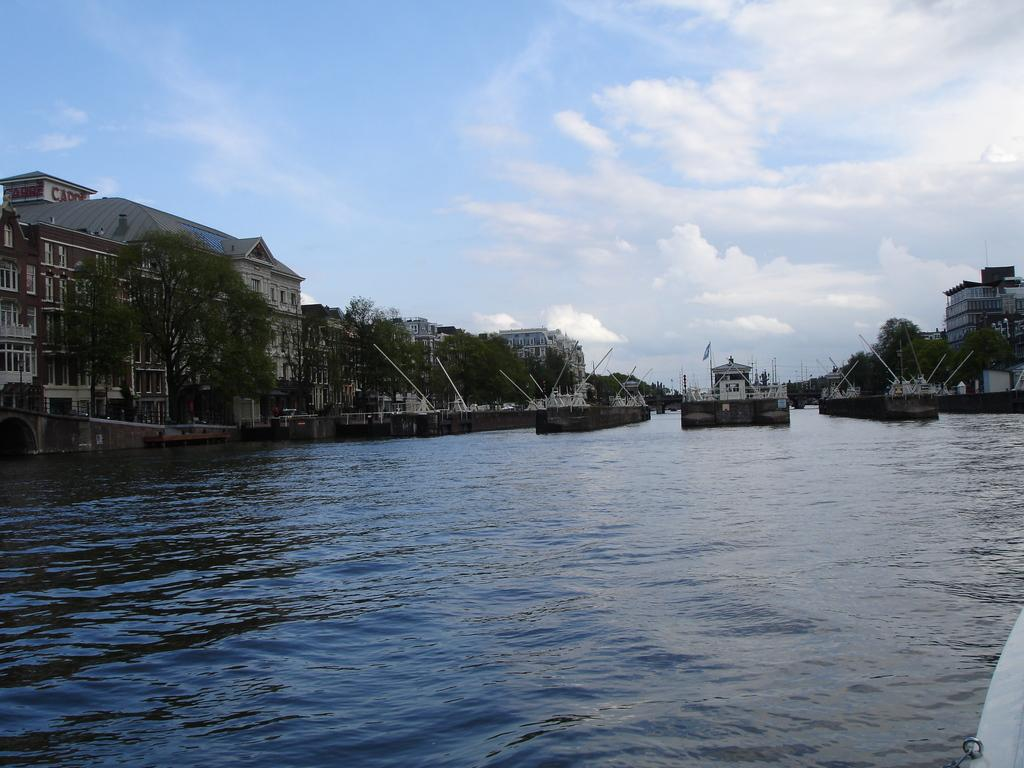What is present at the bottom of the image? There is water at the bottom of the image. What can be seen in the middle of the image? There are trees and buildings in the middle of the image. What is visible at the top of the image? The sky is visible at the top of the image. What is the condition of the sky in the image? The sky is cloudy in the image. How many legs can be seen on the volcano in the image? There is no volcano present in the image. What type of umbrella is being used by the trees in the image? There are no umbrellas present in the image; it features trees, buildings, water, and a cloudy sky. 